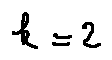<formula> <loc_0><loc_0><loc_500><loc_500>k = 2</formula> 